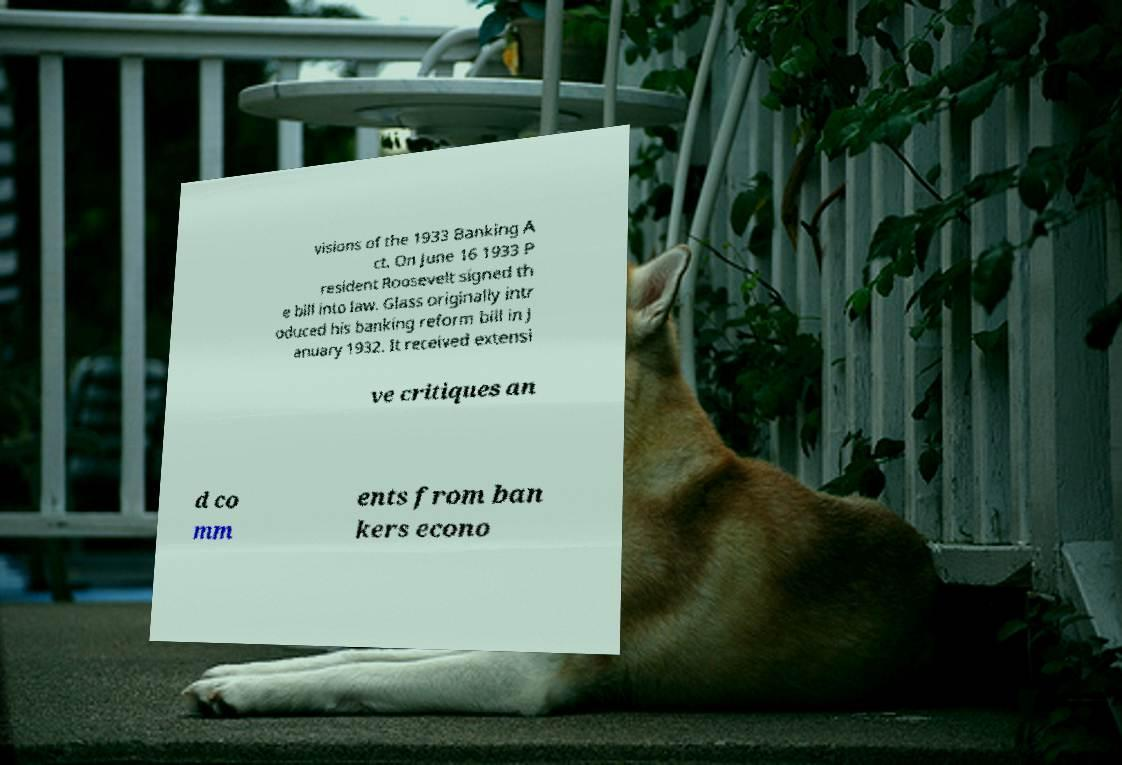For documentation purposes, I need the text within this image transcribed. Could you provide that? visions of the 1933 Banking A ct. On June 16 1933 P resident Roosevelt signed th e bill into law. Glass originally intr oduced his banking reform bill in J anuary 1932. It received extensi ve critiques an d co mm ents from ban kers econo 